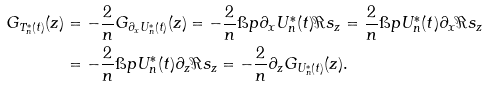<formula> <loc_0><loc_0><loc_500><loc_500>G _ { T _ { n } ^ { \ast } ( t ) } ( z ) & = - \frac { 2 } { n } G _ { \partial _ { x } U _ { n } ^ { \ast } ( t ) } ( z ) = - \frac { 2 } { n } \i p { \partial _ { x } U _ { n } ^ { \ast } ( t ) } { \Re s _ { z } } = \frac { 2 } { n } \i p { U _ { n } ^ { \ast } ( t ) } { \partial _ { x } \Re s _ { z } } \\ & = - \frac { 2 } { n } \i p { U _ { n } ^ { \ast } ( t ) } { \partial _ { z } \Re s _ { z } } = - \frac { 2 } { n } \partial _ { z } G _ { U _ { n } ^ { \ast } ( t ) } ( z ) .</formula> 